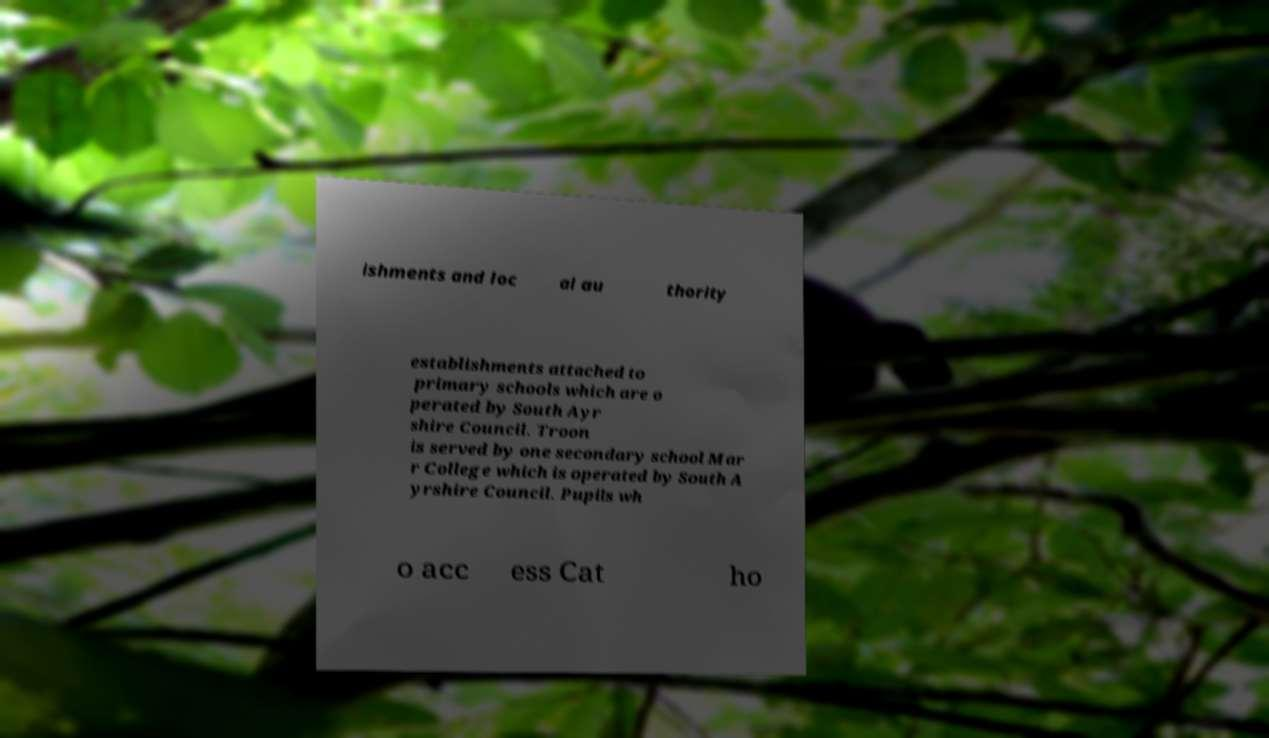Please read and relay the text visible in this image. What does it say? ishments and loc al au thority establishments attached to primary schools which are o perated by South Ayr shire Council. Troon is served by one secondary school Mar r College which is operated by South A yrshire Council. Pupils wh o acc ess Cat ho 